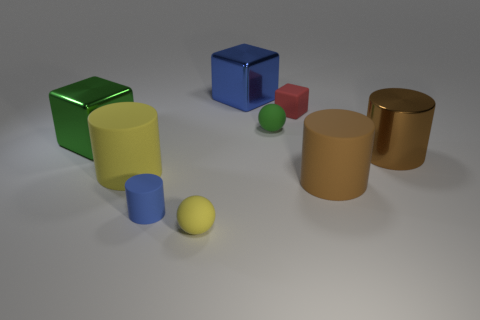Subtract all brown matte cylinders. How many cylinders are left? 3 Subtract all brown cylinders. How many cylinders are left? 2 Subtract all green spheres. How many brown cylinders are left? 2 Subtract all cylinders. How many objects are left? 5 Subtract 0 gray balls. How many objects are left? 9 Subtract all purple cubes. Subtract all gray spheres. How many cubes are left? 3 Subtract all tiny blue rubber cylinders. Subtract all yellow rubber cylinders. How many objects are left? 7 Add 8 red matte objects. How many red matte objects are left? 9 Add 8 blue rubber objects. How many blue rubber objects exist? 9 